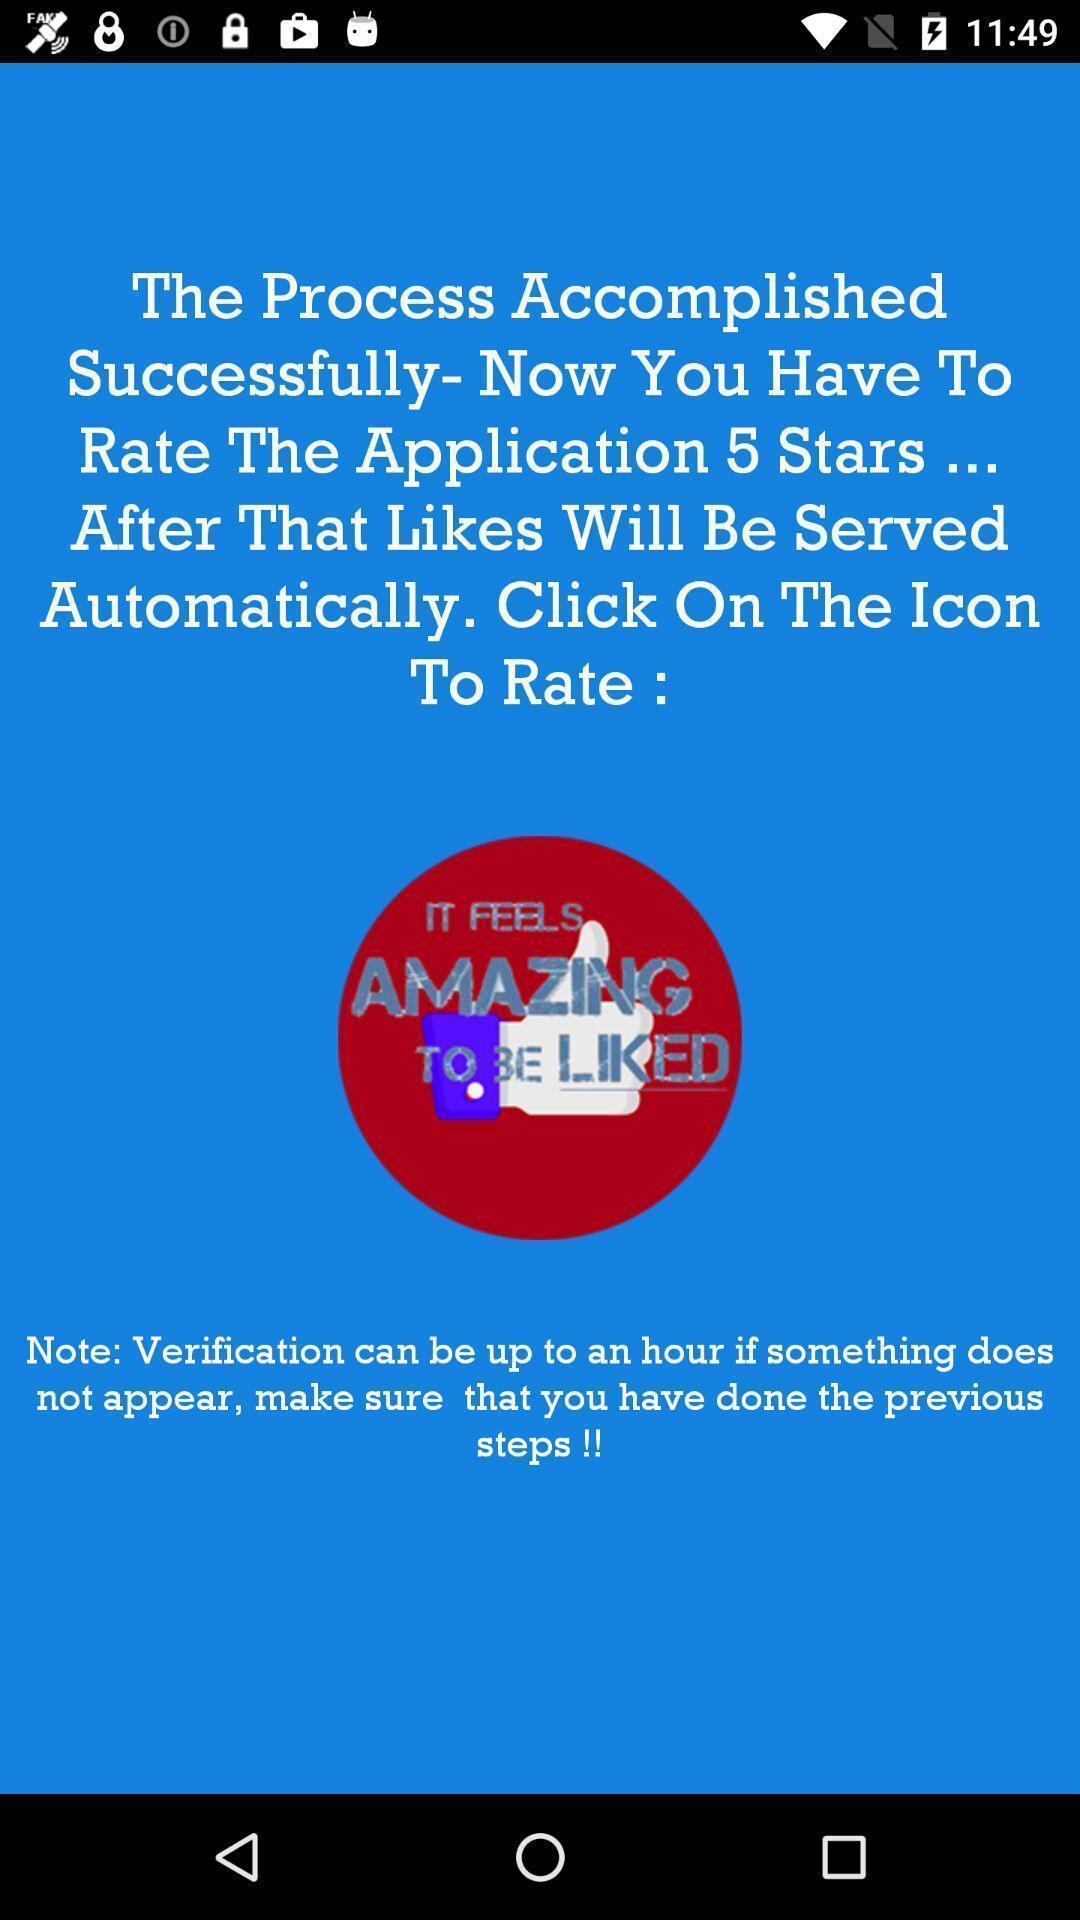Describe the content in this image. Rating page displayed. 